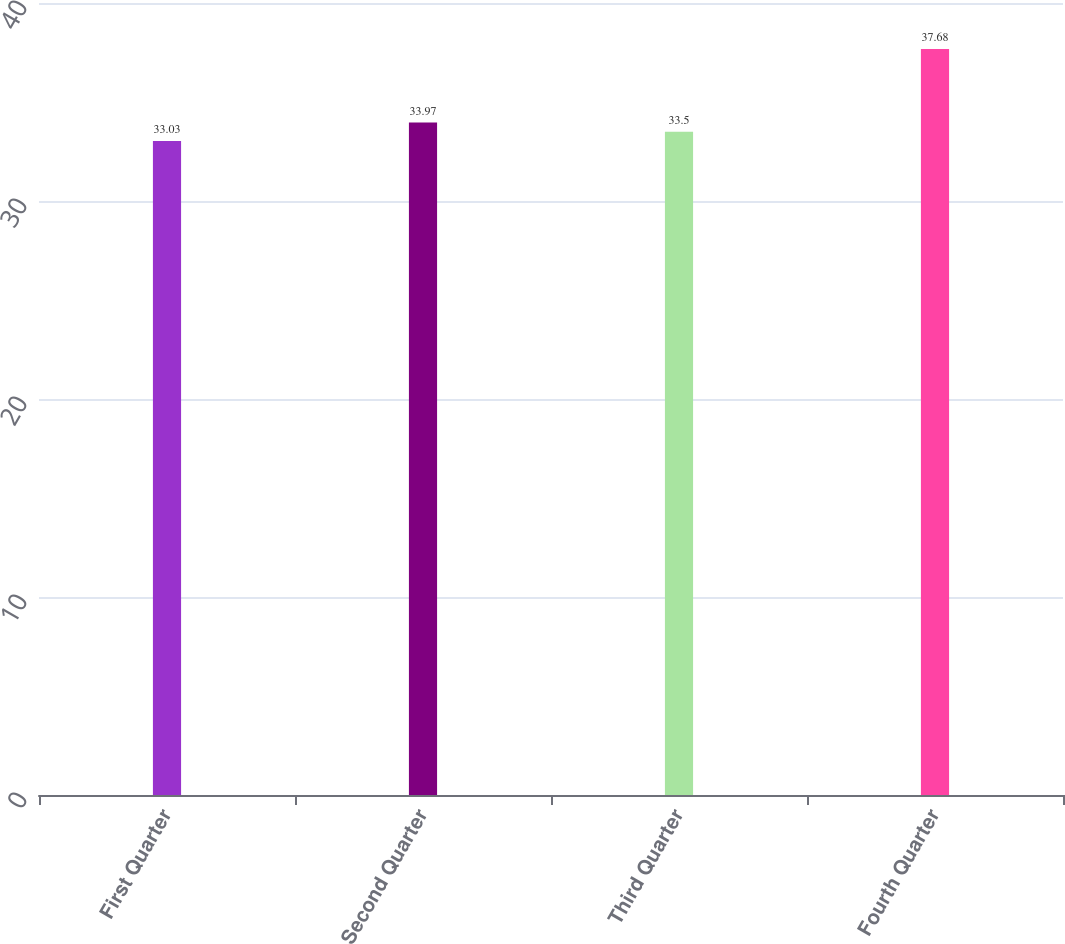Convert chart to OTSL. <chart><loc_0><loc_0><loc_500><loc_500><bar_chart><fcel>First Quarter<fcel>Second Quarter<fcel>Third Quarter<fcel>Fourth Quarter<nl><fcel>33.03<fcel>33.97<fcel>33.5<fcel>37.68<nl></chart> 